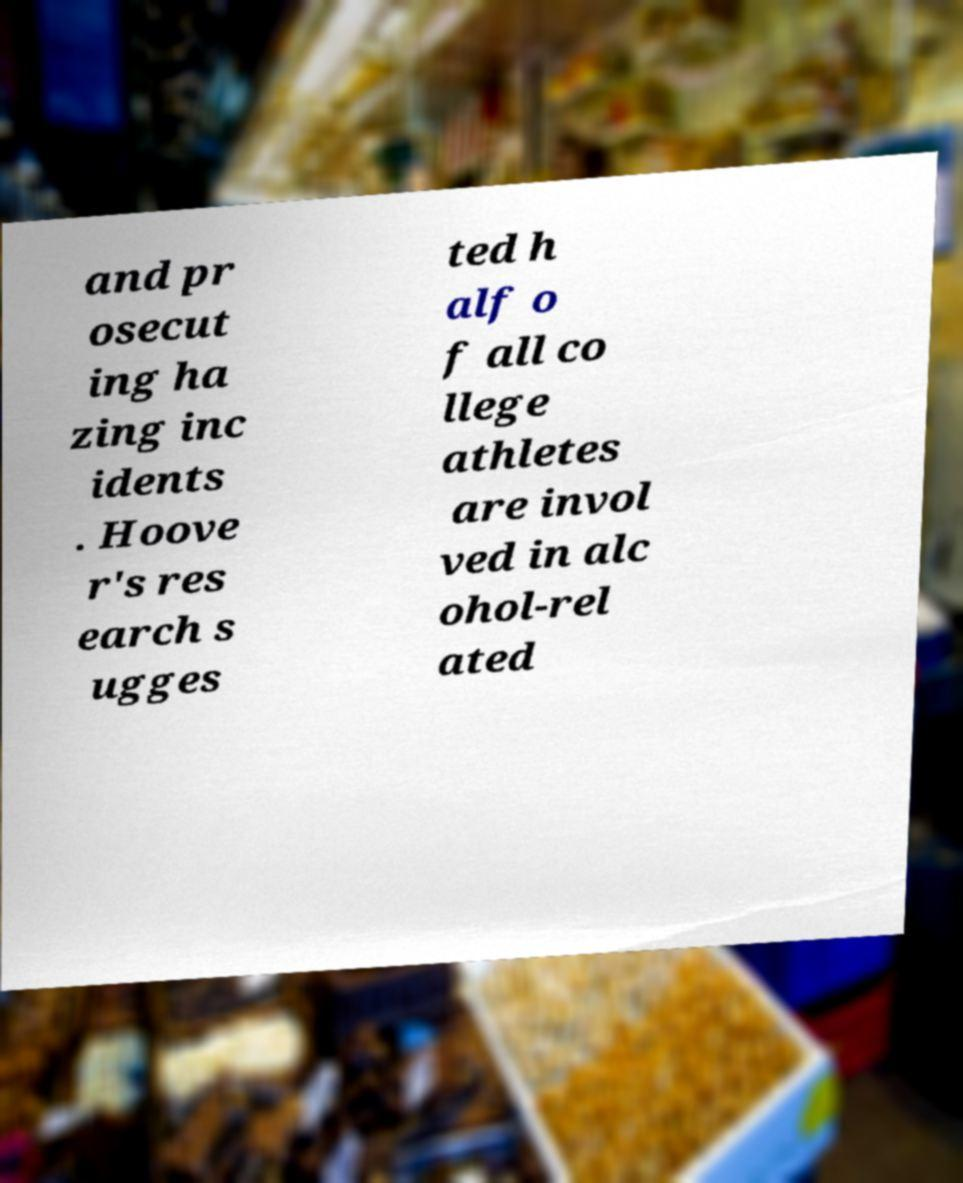Could you assist in decoding the text presented in this image and type it out clearly? and pr osecut ing ha zing inc idents . Hoove r's res earch s ugges ted h alf o f all co llege athletes are invol ved in alc ohol-rel ated 